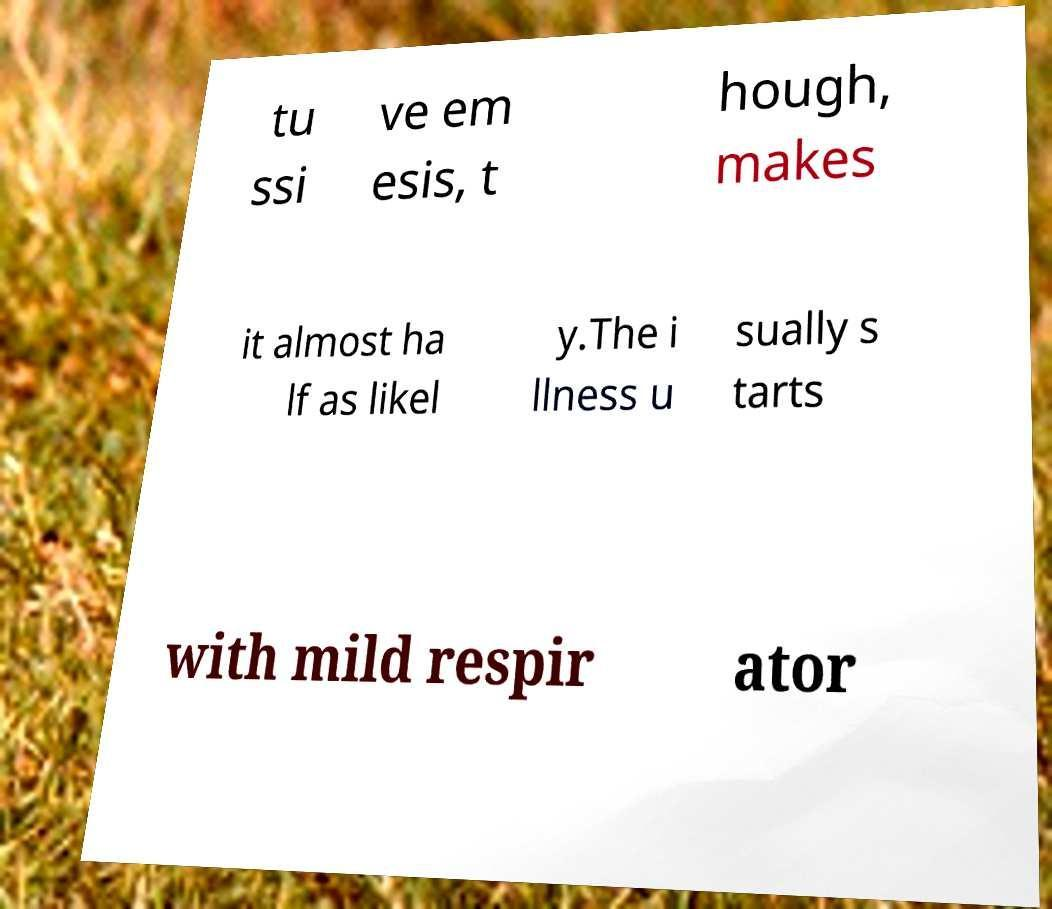Could you assist in decoding the text presented in this image and type it out clearly? tu ssi ve em esis, t hough, makes it almost ha lf as likel y.The i llness u sually s tarts with mild respir ator 